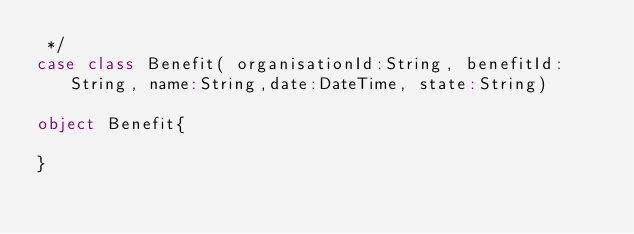<code> <loc_0><loc_0><loc_500><loc_500><_Scala_> */
case class Benefit( organisationId:String, benefitId:String, name:String,date:DateTime, state:String)

object Benefit{

}
</code> 